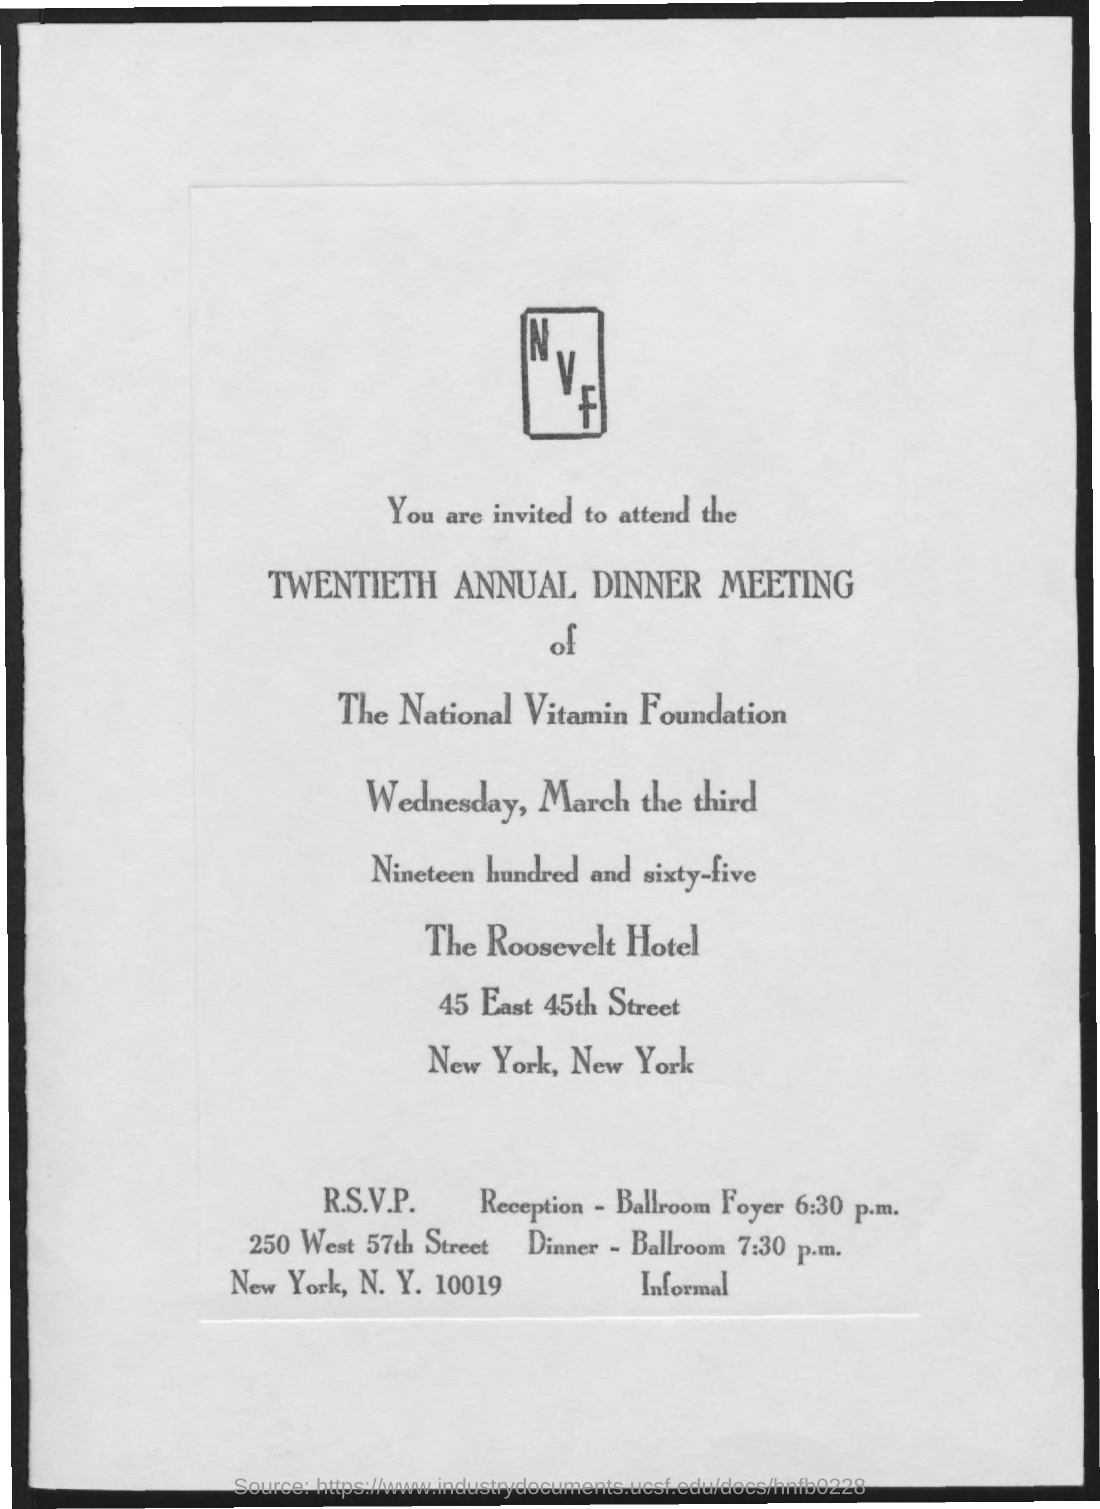List a handful of essential elements in this visual. The invitation is for the Twentieth Annual Dinner Meeting. The location of dinner is the ballroom. The reception is located in the ballroom foyer. 